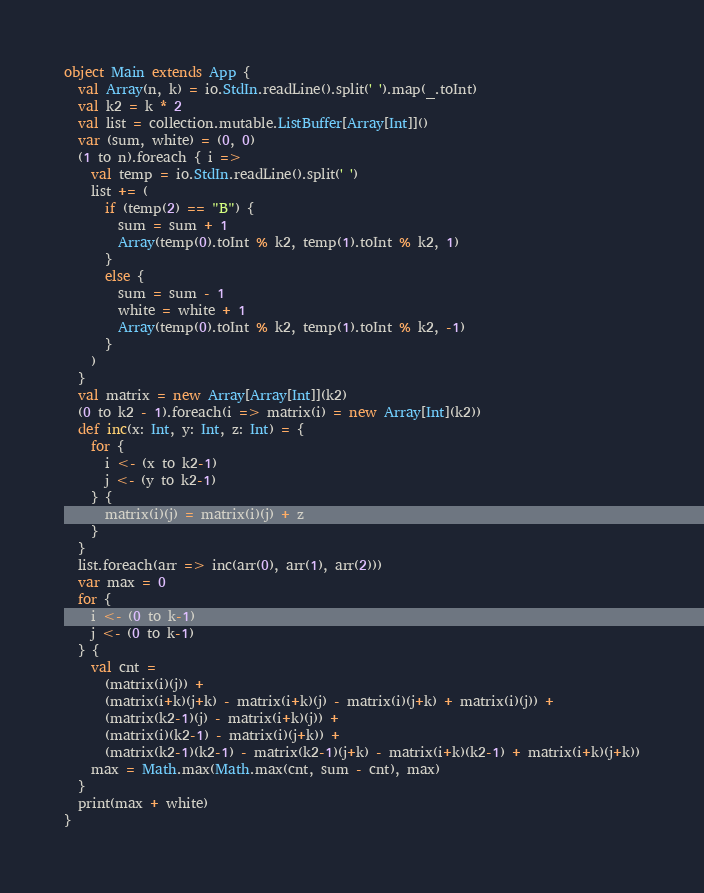Convert code to text. <code><loc_0><loc_0><loc_500><loc_500><_Scala_>object Main extends App {
  val Array(n, k) = io.StdIn.readLine().split(' ').map(_.toInt)
  val k2 = k * 2
  val list = collection.mutable.ListBuffer[Array[Int]]()
  var (sum, white) = (0, 0)
  (1 to n).foreach { i =>
    val temp = io.StdIn.readLine().split(' ')
    list += (
      if (temp(2) == "B") {
        sum = sum + 1
        Array(temp(0).toInt % k2, temp(1).toInt % k2, 1)
      }
      else {
        sum = sum - 1
        white = white + 1
        Array(temp(0).toInt % k2, temp(1).toInt % k2, -1)
      }
    )
  }
  val matrix = new Array[Array[Int]](k2)
  (0 to k2 - 1).foreach(i => matrix(i) = new Array[Int](k2))
  def inc(x: Int, y: Int, z: Int) = {
    for {
      i <- (x to k2-1)
      j <- (y to k2-1)
    } {
      matrix(i)(j) = matrix(i)(j) + z
    }
  }
  list.foreach(arr => inc(arr(0), arr(1), arr(2)))
  var max = 0
  for { 
    i <- (0 to k-1)
    j <- (0 to k-1)
  } {
    val cnt = 
      (matrix(i)(j)) +
      (matrix(i+k)(j+k) - matrix(i+k)(j) - matrix(i)(j+k) + matrix(i)(j)) +
      (matrix(k2-1)(j) - matrix(i+k)(j)) +
      (matrix(i)(k2-1) - matrix(i)(j+k)) +
      (matrix(k2-1)(k2-1) - matrix(k2-1)(j+k) - matrix(i+k)(k2-1) + matrix(i+k)(j+k))
    max = Math.max(Math.max(cnt, sum - cnt), max)
  }
  print(max + white)
}
</code> 